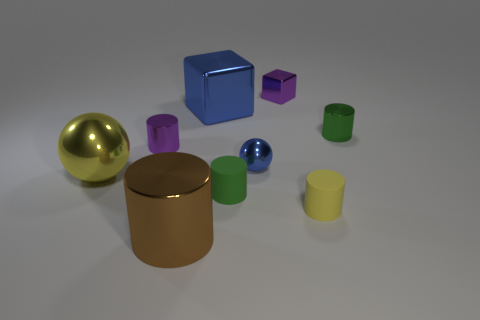There is a cylinder on the right side of the yellow cylinder; what is its color?
Give a very brief answer. Green. There is a yellow matte object that is the same size as the green metal cylinder; what shape is it?
Your answer should be very brief. Cylinder. How many blocks are on the right side of the large blue block?
Offer a terse response. 1. How many things are either tiny yellow objects or big balls?
Offer a very short reply. 2. What is the shape of the tiny thing that is both behind the small purple cylinder and left of the tiny yellow thing?
Give a very brief answer. Cube. How many tiny green metallic blocks are there?
Give a very brief answer. 0. There is a small object that is made of the same material as the small yellow cylinder; what is its color?
Offer a terse response. Green. Are there more big yellow things than gray blocks?
Provide a succinct answer. Yes. There is a cylinder that is both on the right side of the purple cube and behind the small yellow matte cylinder; what size is it?
Make the answer very short. Small. There is a thing that is the same color as the tiny shiny ball; what is its material?
Give a very brief answer. Metal. 